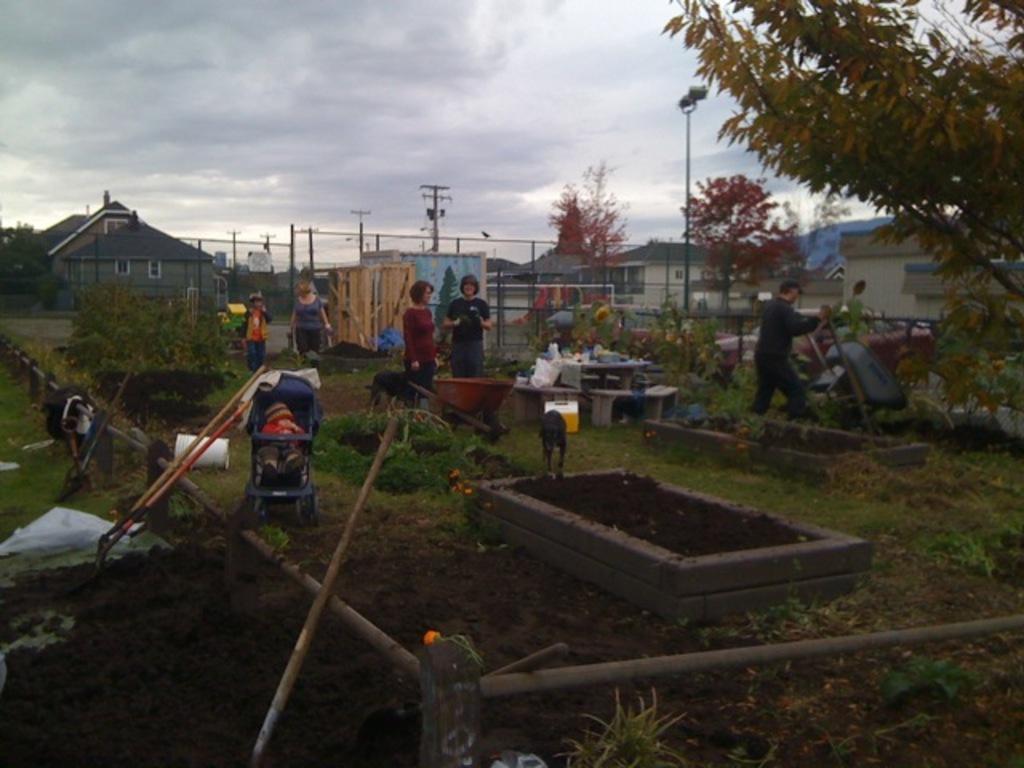Could you give a brief overview of what you see in this image? In this image, we can see few trees, plants, people, poles, sticks, houses, dogs, benches. Here there is a stroller. Baby is there inside. Background there is a cloudy sky. 